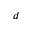Convert formula to latex. <formula><loc_0><loc_0><loc_500><loc_500>d</formula> 